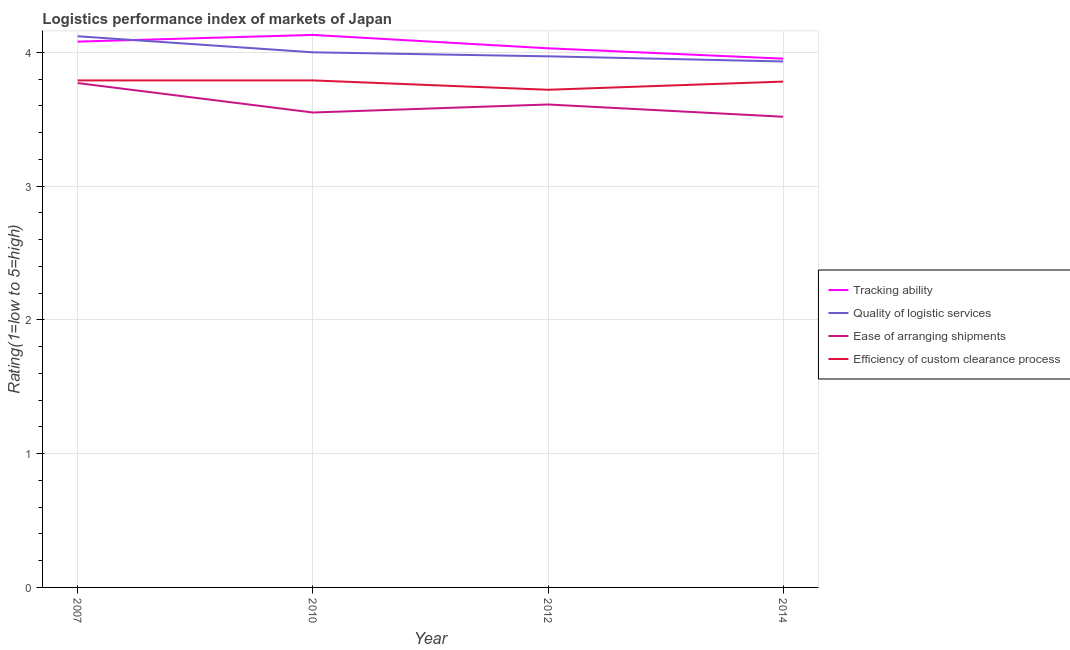What is the lpi rating of ease of arranging shipments in 2007?
Your response must be concise. 3.77. Across all years, what is the maximum lpi rating of tracking ability?
Ensure brevity in your answer.  4.13. Across all years, what is the minimum lpi rating of ease of arranging shipments?
Provide a succinct answer. 3.52. In which year was the lpi rating of tracking ability maximum?
Offer a terse response. 2010. In which year was the lpi rating of efficiency of custom clearance process minimum?
Give a very brief answer. 2012. What is the total lpi rating of tracking ability in the graph?
Ensure brevity in your answer.  16.19. What is the difference between the lpi rating of tracking ability in 2007 and that in 2012?
Make the answer very short. 0.05. What is the difference between the lpi rating of ease of arranging shipments in 2007 and the lpi rating of quality of logistic services in 2010?
Provide a succinct answer. -0.23. What is the average lpi rating of quality of logistic services per year?
Give a very brief answer. 4.01. In the year 2014, what is the difference between the lpi rating of ease of arranging shipments and lpi rating of efficiency of custom clearance process?
Make the answer very short. -0.26. What is the ratio of the lpi rating of ease of arranging shipments in 2010 to that in 2012?
Offer a terse response. 0.98. Is the lpi rating of quality of logistic services in 2010 less than that in 2014?
Offer a very short reply. No. Is the difference between the lpi rating of tracking ability in 2010 and 2012 greater than the difference between the lpi rating of ease of arranging shipments in 2010 and 2012?
Provide a short and direct response. Yes. What is the difference between the highest and the second highest lpi rating of ease of arranging shipments?
Your answer should be compact. 0.16. What is the difference between the highest and the lowest lpi rating of efficiency of custom clearance process?
Provide a short and direct response. 0.07. In how many years, is the lpi rating of ease of arranging shipments greater than the average lpi rating of ease of arranging shipments taken over all years?
Your answer should be very brief. 1. Is the sum of the lpi rating of tracking ability in 2007 and 2010 greater than the maximum lpi rating of quality of logistic services across all years?
Your answer should be very brief. Yes. Does the lpi rating of ease of arranging shipments monotonically increase over the years?
Your response must be concise. No. Is the lpi rating of quality of logistic services strictly less than the lpi rating of ease of arranging shipments over the years?
Your answer should be very brief. No. How many years are there in the graph?
Give a very brief answer. 4. Are the values on the major ticks of Y-axis written in scientific E-notation?
Keep it short and to the point. No. Does the graph contain any zero values?
Give a very brief answer. No. Where does the legend appear in the graph?
Your answer should be very brief. Center right. What is the title of the graph?
Offer a very short reply. Logistics performance index of markets of Japan. Does "Taxes on revenue" appear as one of the legend labels in the graph?
Offer a very short reply. No. What is the label or title of the X-axis?
Make the answer very short. Year. What is the label or title of the Y-axis?
Your response must be concise. Rating(1=low to 5=high). What is the Rating(1=low to 5=high) in Tracking ability in 2007?
Offer a very short reply. 4.08. What is the Rating(1=low to 5=high) in Quality of logistic services in 2007?
Offer a very short reply. 4.12. What is the Rating(1=low to 5=high) in Ease of arranging shipments in 2007?
Your answer should be very brief. 3.77. What is the Rating(1=low to 5=high) in Efficiency of custom clearance process in 2007?
Offer a terse response. 3.79. What is the Rating(1=low to 5=high) of Tracking ability in 2010?
Provide a succinct answer. 4.13. What is the Rating(1=low to 5=high) of Ease of arranging shipments in 2010?
Offer a terse response. 3.55. What is the Rating(1=low to 5=high) in Efficiency of custom clearance process in 2010?
Give a very brief answer. 3.79. What is the Rating(1=low to 5=high) in Tracking ability in 2012?
Ensure brevity in your answer.  4.03. What is the Rating(1=low to 5=high) of Quality of logistic services in 2012?
Offer a terse response. 3.97. What is the Rating(1=low to 5=high) in Ease of arranging shipments in 2012?
Your answer should be compact. 3.61. What is the Rating(1=low to 5=high) in Efficiency of custom clearance process in 2012?
Your answer should be very brief. 3.72. What is the Rating(1=low to 5=high) in Tracking ability in 2014?
Your response must be concise. 3.95. What is the Rating(1=low to 5=high) in Quality of logistic services in 2014?
Offer a terse response. 3.93. What is the Rating(1=low to 5=high) of Ease of arranging shipments in 2014?
Give a very brief answer. 3.52. What is the Rating(1=low to 5=high) in Efficiency of custom clearance process in 2014?
Give a very brief answer. 3.78. Across all years, what is the maximum Rating(1=low to 5=high) of Tracking ability?
Your answer should be compact. 4.13. Across all years, what is the maximum Rating(1=low to 5=high) in Quality of logistic services?
Keep it short and to the point. 4.12. Across all years, what is the maximum Rating(1=low to 5=high) in Ease of arranging shipments?
Offer a very short reply. 3.77. Across all years, what is the maximum Rating(1=low to 5=high) of Efficiency of custom clearance process?
Give a very brief answer. 3.79. Across all years, what is the minimum Rating(1=low to 5=high) in Tracking ability?
Offer a very short reply. 3.95. Across all years, what is the minimum Rating(1=low to 5=high) of Quality of logistic services?
Ensure brevity in your answer.  3.93. Across all years, what is the minimum Rating(1=low to 5=high) in Ease of arranging shipments?
Provide a succinct answer. 3.52. Across all years, what is the minimum Rating(1=low to 5=high) of Efficiency of custom clearance process?
Your answer should be compact. 3.72. What is the total Rating(1=low to 5=high) of Tracking ability in the graph?
Your answer should be compact. 16.19. What is the total Rating(1=low to 5=high) of Quality of logistic services in the graph?
Offer a terse response. 16.02. What is the total Rating(1=low to 5=high) of Ease of arranging shipments in the graph?
Ensure brevity in your answer.  14.45. What is the total Rating(1=low to 5=high) in Efficiency of custom clearance process in the graph?
Your response must be concise. 15.08. What is the difference between the Rating(1=low to 5=high) in Quality of logistic services in 2007 and that in 2010?
Your response must be concise. 0.12. What is the difference between the Rating(1=low to 5=high) in Ease of arranging shipments in 2007 and that in 2010?
Offer a very short reply. 0.22. What is the difference between the Rating(1=low to 5=high) of Efficiency of custom clearance process in 2007 and that in 2010?
Give a very brief answer. 0. What is the difference between the Rating(1=low to 5=high) in Tracking ability in 2007 and that in 2012?
Your response must be concise. 0.05. What is the difference between the Rating(1=low to 5=high) of Quality of logistic services in 2007 and that in 2012?
Your answer should be compact. 0.15. What is the difference between the Rating(1=low to 5=high) of Ease of arranging shipments in 2007 and that in 2012?
Your answer should be compact. 0.16. What is the difference between the Rating(1=low to 5=high) in Efficiency of custom clearance process in 2007 and that in 2012?
Provide a short and direct response. 0.07. What is the difference between the Rating(1=low to 5=high) in Tracking ability in 2007 and that in 2014?
Offer a very short reply. 0.13. What is the difference between the Rating(1=low to 5=high) in Quality of logistic services in 2007 and that in 2014?
Provide a short and direct response. 0.19. What is the difference between the Rating(1=low to 5=high) of Ease of arranging shipments in 2007 and that in 2014?
Keep it short and to the point. 0.25. What is the difference between the Rating(1=low to 5=high) in Efficiency of custom clearance process in 2007 and that in 2014?
Provide a short and direct response. 0.01. What is the difference between the Rating(1=low to 5=high) of Quality of logistic services in 2010 and that in 2012?
Keep it short and to the point. 0.03. What is the difference between the Rating(1=low to 5=high) in Ease of arranging shipments in 2010 and that in 2012?
Keep it short and to the point. -0.06. What is the difference between the Rating(1=low to 5=high) of Efficiency of custom clearance process in 2010 and that in 2012?
Give a very brief answer. 0.07. What is the difference between the Rating(1=low to 5=high) in Tracking ability in 2010 and that in 2014?
Make the answer very short. 0.18. What is the difference between the Rating(1=low to 5=high) of Quality of logistic services in 2010 and that in 2014?
Your answer should be compact. 0.07. What is the difference between the Rating(1=low to 5=high) in Ease of arranging shipments in 2010 and that in 2014?
Your answer should be very brief. 0.03. What is the difference between the Rating(1=low to 5=high) of Efficiency of custom clearance process in 2010 and that in 2014?
Offer a terse response. 0.01. What is the difference between the Rating(1=low to 5=high) in Tracking ability in 2012 and that in 2014?
Ensure brevity in your answer.  0.08. What is the difference between the Rating(1=low to 5=high) of Quality of logistic services in 2012 and that in 2014?
Your answer should be very brief. 0.04. What is the difference between the Rating(1=low to 5=high) in Ease of arranging shipments in 2012 and that in 2014?
Your answer should be very brief. 0.09. What is the difference between the Rating(1=low to 5=high) in Efficiency of custom clearance process in 2012 and that in 2014?
Your response must be concise. -0.06. What is the difference between the Rating(1=low to 5=high) of Tracking ability in 2007 and the Rating(1=low to 5=high) of Ease of arranging shipments in 2010?
Provide a short and direct response. 0.53. What is the difference between the Rating(1=low to 5=high) of Tracking ability in 2007 and the Rating(1=low to 5=high) of Efficiency of custom clearance process in 2010?
Your response must be concise. 0.29. What is the difference between the Rating(1=low to 5=high) in Quality of logistic services in 2007 and the Rating(1=low to 5=high) in Ease of arranging shipments in 2010?
Keep it short and to the point. 0.57. What is the difference between the Rating(1=low to 5=high) in Quality of logistic services in 2007 and the Rating(1=low to 5=high) in Efficiency of custom clearance process in 2010?
Provide a short and direct response. 0.33. What is the difference between the Rating(1=low to 5=high) of Ease of arranging shipments in 2007 and the Rating(1=low to 5=high) of Efficiency of custom clearance process in 2010?
Your answer should be very brief. -0.02. What is the difference between the Rating(1=low to 5=high) in Tracking ability in 2007 and the Rating(1=low to 5=high) in Quality of logistic services in 2012?
Ensure brevity in your answer.  0.11. What is the difference between the Rating(1=low to 5=high) in Tracking ability in 2007 and the Rating(1=low to 5=high) in Ease of arranging shipments in 2012?
Your answer should be compact. 0.47. What is the difference between the Rating(1=low to 5=high) of Tracking ability in 2007 and the Rating(1=low to 5=high) of Efficiency of custom clearance process in 2012?
Make the answer very short. 0.36. What is the difference between the Rating(1=low to 5=high) in Quality of logistic services in 2007 and the Rating(1=low to 5=high) in Ease of arranging shipments in 2012?
Make the answer very short. 0.51. What is the difference between the Rating(1=low to 5=high) in Ease of arranging shipments in 2007 and the Rating(1=low to 5=high) in Efficiency of custom clearance process in 2012?
Offer a terse response. 0.05. What is the difference between the Rating(1=low to 5=high) in Tracking ability in 2007 and the Rating(1=low to 5=high) in Quality of logistic services in 2014?
Give a very brief answer. 0.15. What is the difference between the Rating(1=low to 5=high) in Tracking ability in 2007 and the Rating(1=low to 5=high) in Ease of arranging shipments in 2014?
Ensure brevity in your answer.  0.56. What is the difference between the Rating(1=low to 5=high) of Tracking ability in 2007 and the Rating(1=low to 5=high) of Efficiency of custom clearance process in 2014?
Your answer should be very brief. 0.3. What is the difference between the Rating(1=low to 5=high) of Quality of logistic services in 2007 and the Rating(1=low to 5=high) of Ease of arranging shipments in 2014?
Provide a succinct answer. 0.6. What is the difference between the Rating(1=low to 5=high) in Quality of logistic services in 2007 and the Rating(1=low to 5=high) in Efficiency of custom clearance process in 2014?
Your answer should be compact. 0.34. What is the difference between the Rating(1=low to 5=high) of Ease of arranging shipments in 2007 and the Rating(1=low to 5=high) of Efficiency of custom clearance process in 2014?
Offer a very short reply. -0.01. What is the difference between the Rating(1=low to 5=high) in Tracking ability in 2010 and the Rating(1=low to 5=high) in Quality of logistic services in 2012?
Your response must be concise. 0.16. What is the difference between the Rating(1=low to 5=high) in Tracking ability in 2010 and the Rating(1=low to 5=high) in Ease of arranging shipments in 2012?
Make the answer very short. 0.52. What is the difference between the Rating(1=low to 5=high) in Tracking ability in 2010 and the Rating(1=low to 5=high) in Efficiency of custom clearance process in 2012?
Provide a succinct answer. 0.41. What is the difference between the Rating(1=low to 5=high) in Quality of logistic services in 2010 and the Rating(1=low to 5=high) in Ease of arranging shipments in 2012?
Give a very brief answer. 0.39. What is the difference between the Rating(1=low to 5=high) in Quality of logistic services in 2010 and the Rating(1=low to 5=high) in Efficiency of custom clearance process in 2012?
Your answer should be very brief. 0.28. What is the difference between the Rating(1=low to 5=high) in Ease of arranging shipments in 2010 and the Rating(1=low to 5=high) in Efficiency of custom clearance process in 2012?
Ensure brevity in your answer.  -0.17. What is the difference between the Rating(1=low to 5=high) of Tracking ability in 2010 and the Rating(1=low to 5=high) of Quality of logistic services in 2014?
Your answer should be compact. 0.2. What is the difference between the Rating(1=low to 5=high) in Tracking ability in 2010 and the Rating(1=low to 5=high) in Ease of arranging shipments in 2014?
Give a very brief answer. 0.61. What is the difference between the Rating(1=low to 5=high) in Tracking ability in 2010 and the Rating(1=low to 5=high) in Efficiency of custom clearance process in 2014?
Provide a short and direct response. 0.35. What is the difference between the Rating(1=low to 5=high) in Quality of logistic services in 2010 and the Rating(1=low to 5=high) in Ease of arranging shipments in 2014?
Keep it short and to the point. 0.48. What is the difference between the Rating(1=low to 5=high) in Quality of logistic services in 2010 and the Rating(1=low to 5=high) in Efficiency of custom clearance process in 2014?
Keep it short and to the point. 0.22. What is the difference between the Rating(1=low to 5=high) of Ease of arranging shipments in 2010 and the Rating(1=low to 5=high) of Efficiency of custom clearance process in 2014?
Your answer should be very brief. -0.23. What is the difference between the Rating(1=low to 5=high) of Tracking ability in 2012 and the Rating(1=low to 5=high) of Quality of logistic services in 2014?
Provide a short and direct response. 0.1. What is the difference between the Rating(1=low to 5=high) of Tracking ability in 2012 and the Rating(1=low to 5=high) of Ease of arranging shipments in 2014?
Provide a short and direct response. 0.51. What is the difference between the Rating(1=low to 5=high) of Tracking ability in 2012 and the Rating(1=low to 5=high) of Efficiency of custom clearance process in 2014?
Provide a succinct answer. 0.25. What is the difference between the Rating(1=low to 5=high) of Quality of logistic services in 2012 and the Rating(1=low to 5=high) of Ease of arranging shipments in 2014?
Keep it short and to the point. 0.45. What is the difference between the Rating(1=low to 5=high) in Quality of logistic services in 2012 and the Rating(1=low to 5=high) in Efficiency of custom clearance process in 2014?
Provide a succinct answer. 0.19. What is the difference between the Rating(1=low to 5=high) of Ease of arranging shipments in 2012 and the Rating(1=low to 5=high) of Efficiency of custom clearance process in 2014?
Keep it short and to the point. -0.17. What is the average Rating(1=low to 5=high) in Tracking ability per year?
Provide a short and direct response. 4.05. What is the average Rating(1=low to 5=high) in Quality of logistic services per year?
Your answer should be very brief. 4.01. What is the average Rating(1=low to 5=high) of Ease of arranging shipments per year?
Offer a very short reply. 3.61. What is the average Rating(1=low to 5=high) in Efficiency of custom clearance process per year?
Offer a terse response. 3.77. In the year 2007, what is the difference between the Rating(1=low to 5=high) of Tracking ability and Rating(1=low to 5=high) of Quality of logistic services?
Your answer should be compact. -0.04. In the year 2007, what is the difference between the Rating(1=low to 5=high) of Tracking ability and Rating(1=low to 5=high) of Ease of arranging shipments?
Make the answer very short. 0.31. In the year 2007, what is the difference between the Rating(1=low to 5=high) of Tracking ability and Rating(1=low to 5=high) of Efficiency of custom clearance process?
Your answer should be compact. 0.29. In the year 2007, what is the difference between the Rating(1=low to 5=high) of Quality of logistic services and Rating(1=low to 5=high) of Ease of arranging shipments?
Ensure brevity in your answer.  0.35. In the year 2007, what is the difference between the Rating(1=low to 5=high) of Quality of logistic services and Rating(1=low to 5=high) of Efficiency of custom clearance process?
Your response must be concise. 0.33. In the year 2007, what is the difference between the Rating(1=low to 5=high) in Ease of arranging shipments and Rating(1=low to 5=high) in Efficiency of custom clearance process?
Your response must be concise. -0.02. In the year 2010, what is the difference between the Rating(1=low to 5=high) of Tracking ability and Rating(1=low to 5=high) of Quality of logistic services?
Ensure brevity in your answer.  0.13. In the year 2010, what is the difference between the Rating(1=low to 5=high) of Tracking ability and Rating(1=low to 5=high) of Ease of arranging shipments?
Provide a succinct answer. 0.58. In the year 2010, what is the difference between the Rating(1=low to 5=high) of Tracking ability and Rating(1=low to 5=high) of Efficiency of custom clearance process?
Offer a terse response. 0.34. In the year 2010, what is the difference between the Rating(1=low to 5=high) of Quality of logistic services and Rating(1=low to 5=high) of Ease of arranging shipments?
Your answer should be very brief. 0.45. In the year 2010, what is the difference between the Rating(1=low to 5=high) in Quality of logistic services and Rating(1=low to 5=high) in Efficiency of custom clearance process?
Provide a succinct answer. 0.21. In the year 2010, what is the difference between the Rating(1=low to 5=high) of Ease of arranging shipments and Rating(1=low to 5=high) of Efficiency of custom clearance process?
Give a very brief answer. -0.24. In the year 2012, what is the difference between the Rating(1=low to 5=high) of Tracking ability and Rating(1=low to 5=high) of Quality of logistic services?
Ensure brevity in your answer.  0.06. In the year 2012, what is the difference between the Rating(1=low to 5=high) in Tracking ability and Rating(1=low to 5=high) in Ease of arranging shipments?
Your answer should be very brief. 0.42. In the year 2012, what is the difference between the Rating(1=low to 5=high) of Tracking ability and Rating(1=low to 5=high) of Efficiency of custom clearance process?
Give a very brief answer. 0.31. In the year 2012, what is the difference between the Rating(1=low to 5=high) in Quality of logistic services and Rating(1=low to 5=high) in Ease of arranging shipments?
Ensure brevity in your answer.  0.36. In the year 2012, what is the difference between the Rating(1=low to 5=high) in Quality of logistic services and Rating(1=low to 5=high) in Efficiency of custom clearance process?
Provide a succinct answer. 0.25. In the year 2012, what is the difference between the Rating(1=low to 5=high) of Ease of arranging shipments and Rating(1=low to 5=high) of Efficiency of custom clearance process?
Offer a very short reply. -0.11. In the year 2014, what is the difference between the Rating(1=low to 5=high) of Tracking ability and Rating(1=low to 5=high) of Quality of logistic services?
Offer a very short reply. 0.02. In the year 2014, what is the difference between the Rating(1=low to 5=high) of Tracking ability and Rating(1=low to 5=high) of Ease of arranging shipments?
Ensure brevity in your answer.  0.43. In the year 2014, what is the difference between the Rating(1=low to 5=high) in Tracking ability and Rating(1=low to 5=high) in Efficiency of custom clearance process?
Offer a very short reply. 0.17. In the year 2014, what is the difference between the Rating(1=low to 5=high) of Quality of logistic services and Rating(1=low to 5=high) of Ease of arranging shipments?
Make the answer very short. 0.41. In the year 2014, what is the difference between the Rating(1=low to 5=high) in Quality of logistic services and Rating(1=low to 5=high) in Efficiency of custom clearance process?
Provide a succinct answer. 0.15. In the year 2014, what is the difference between the Rating(1=low to 5=high) in Ease of arranging shipments and Rating(1=low to 5=high) in Efficiency of custom clearance process?
Your answer should be very brief. -0.26. What is the ratio of the Rating(1=low to 5=high) of Tracking ability in 2007 to that in 2010?
Provide a succinct answer. 0.99. What is the ratio of the Rating(1=low to 5=high) in Quality of logistic services in 2007 to that in 2010?
Keep it short and to the point. 1.03. What is the ratio of the Rating(1=low to 5=high) in Ease of arranging shipments in 2007 to that in 2010?
Give a very brief answer. 1.06. What is the ratio of the Rating(1=low to 5=high) of Tracking ability in 2007 to that in 2012?
Give a very brief answer. 1.01. What is the ratio of the Rating(1=low to 5=high) in Quality of logistic services in 2007 to that in 2012?
Provide a succinct answer. 1.04. What is the ratio of the Rating(1=low to 5=high) in Ease of arranging shipments in 2007 to that in 2012?
Give a very brief answer. 1.04. What is the ratio of the Rating(1=low to 5=high) of Efficiency of custom clearance process in 2007 to that in 2012?
Your response must be concise. 1.02. What is the ratio of the Rating(1=low to 5=high) in Tracking ability in 2007 to that in 2014?
Keep it short and to the point. 1.03. What is the ratio of the Rating(1=low to 5=high) of Quality of logistic services in 2007 to that in 2014?
Offer a terse response. 1.05. What is the ratio of the Rating(1=low to 5=high) in Ease of arranging shipments in 2007 to that in 2014?
Keep it short and to the point. 1.07. What is the ratio of the Rating(1=low to 5=high) of Tracking ability in 2010 to that in 2012?
Keep it short and to the point. 1.02. What is the ratio of the Rating(1=low to 5=high) of Quality of logistic services in 2010 to that in 2012?
Provide a succinct answer. 1.01. What is the ratio of the Rating(1=low to 5=high) of Ease of arranging shipments in 2010 to that in 2012?
Provide a short and direct response. 0.98. What is the ratio of the Rating(1=low to 5=high) in Efficiency of custom clearance process in 2010 to that in 2012?
Your answer should be very brief. 1.02. What is the ratio of the Rating(1=low to 5=high) in Tracking ability in 2010 to that in 2014?
Your answer should be compact. 1.04. What is the ratio of the Rating(1=low to 5=high) of Quality of logistic services in 2010 to that in 2014?
Offer a terse response. 1.02. What is the ratio of the Rating(1=low to 5=high) of Efficiency of custom clearance process in 2010 to that in 2014?
Your response must be concise. 1. What is the ratio of the Rating(1=low to 5=high) in Tracking ability in 2012 to that in 2014?
Ensure brevity in your answer.  1.02. What is the ratio of the Rating(1=low to 5=high) of Quality of logistic services in 2012 to that in 2014?
Give a very brief answer. 1.01. What is the ratio of the Rating(1=low to 5=high) in Efficiency of custom clearance process in 2012 to that in 2014?
Give a very brief answer. 0.98. What is the difference between the highest and the second highest Rating(1=low to 5=high) in Quality of logistic services?
Offer a terse response. 0.12. What is the difference between the highest and the second highest Rating(1=low to 5=high) of Ease of arranging shipments?
Provide a short and direct response. 0.16. What is the difference between the highest and the second highest Rating(1=low to 5=high) in Efficiency of custom clearance process?
Give a very brief answer. 0. What is the difference between the highest and the lowest Rating(1=low to 5=high) of Tracking ability?
Offer a very short reply. 0.18. What is the difference between the highest and the lowest Rating(1=low to 5=high) of Quality of logistic services?
Provide a short and direct response. 0.19. What is the difference between the highest and the lowest Rating(1=low to 5=high) in Ease of arranging shipments?
Your answer should be very brief. 0.25. What is the difference between the highest and the lowest Rating(1=low to 5=high) of Efficiency of custom clearance process?
Your answer should be very brief. 0.07. 